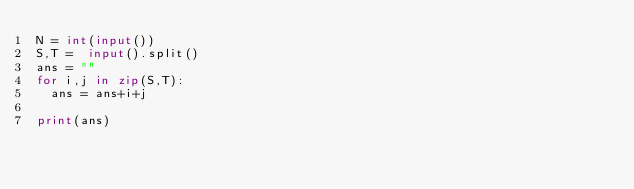<code> <loc_0><loc_0><loc_500><loc_500><_Python_>N = int(input())
S,T =  input().split()
ans = ""
for i,j in zip(S,T):
  ans = ans+i+j
  
print(ans)</code> 